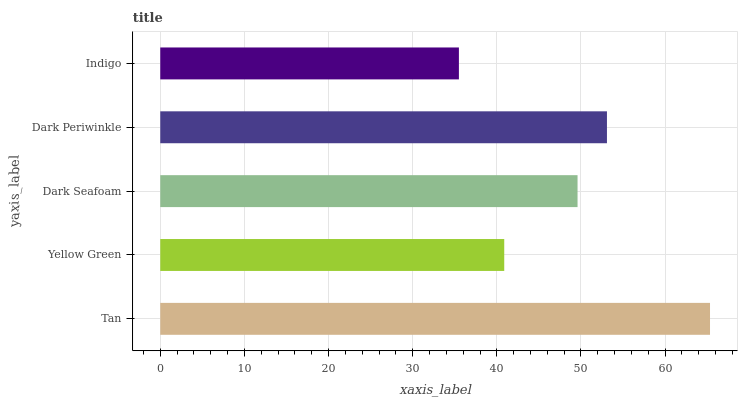Is Indigo the minimum?
Answer yes or no. Yes. Is Tan the maximum?
Answer yes or no. Yes. Is Yellow Green the minimum?
Answer yes or no. No. Is Yellow Green the maximum?
Answer yes or no. No. Is Tan greater than Yellow Green?
Answer yes or no. Yes. Is Yellow Green less than Tan?
Answer yes or no. Yes. Is Yellow Green greater than Tan?
Answer yes or no. No. Is Tan less than Yellow Green?
Answer yes or no. No. Is Dark Seafoam the high median?
Answer yes or no. Yes. Is Dark Seafoam the low median?
Answer yes or no. Yes. Is Indigo the high median?
Answer yes or no. No. Is Yellow Green the low median?
Answer yes or no. No. 